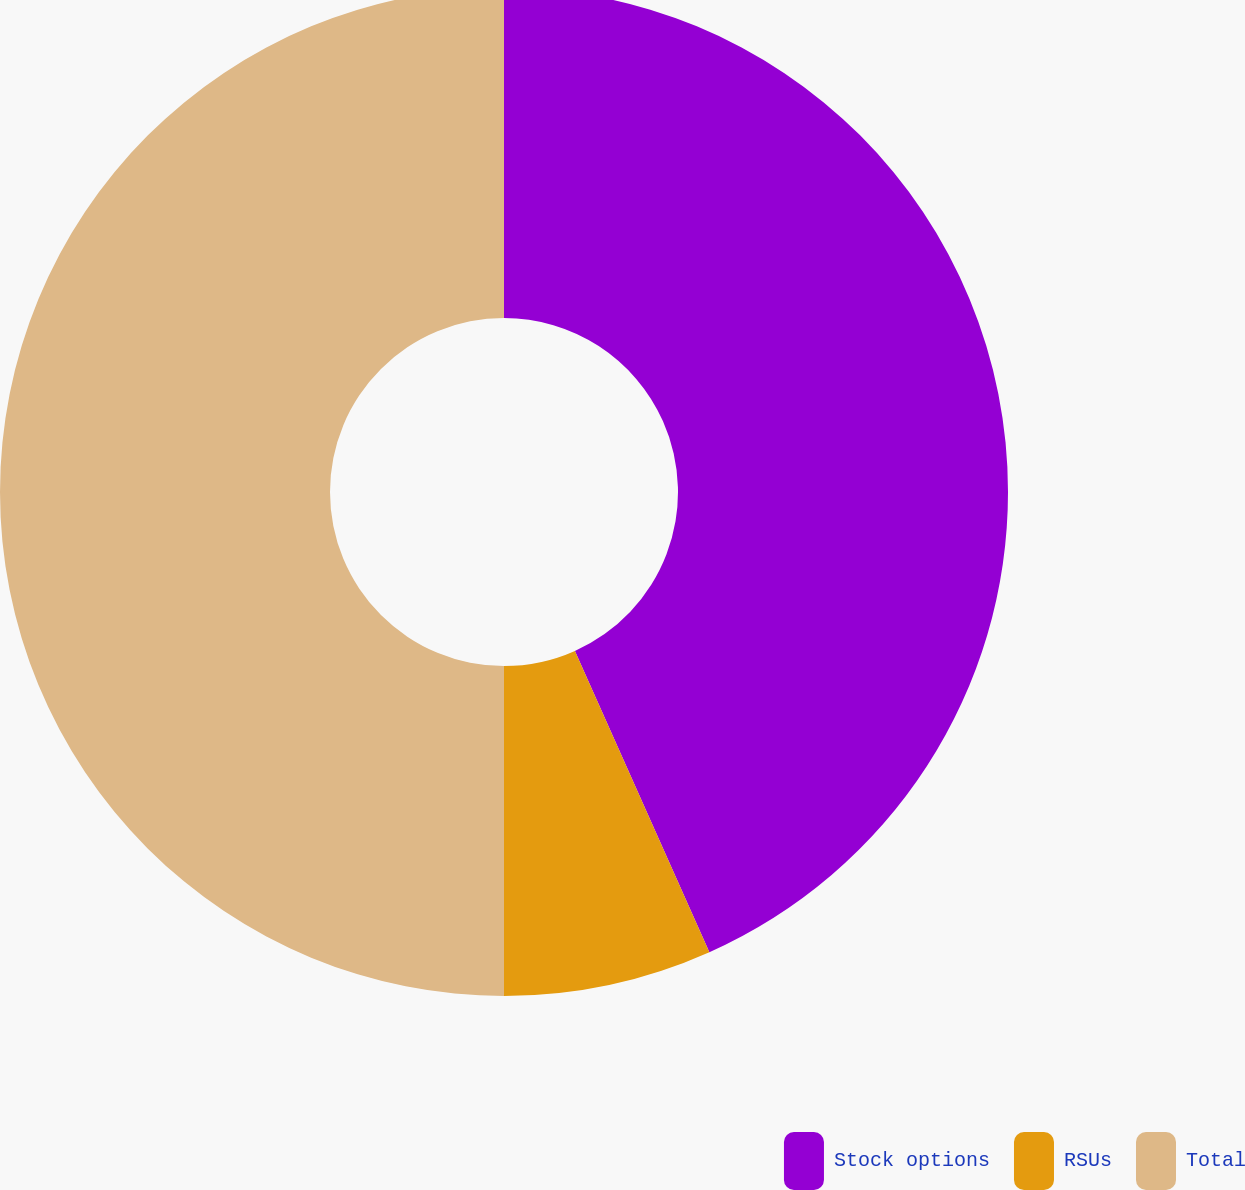Convert chart to OTSL. <chart><loc_0><loc_0><loc_500><loc_500><pie_chart><fcel>Stock options<fcel>RSUs<fcel>Total<nl><fcel>43.32%<fcel>6.68%<fcel>50.0%<nl></chart> 